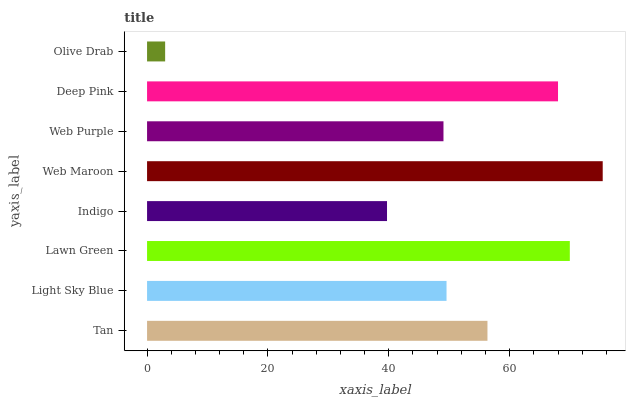Is Olive Drab the minimum?
Answer yes or no. Yes. Is Web Maroon the maximum?
Answer yes or no. Yes. Is Light Sky Blue the minimum?
Answer yes or no. No. Is Light Sky Blue the maximum?
Answer yes or no. No. Is Tan greater than Light Sky Blue?
Answer yes or no. Yes. Is Light Sky Blue less than Tan?
Answer yes or no. Yes. Is Light Sky Blue greater than Tan?
Answer yes or no. No. Is Tan less than Light Sky Blue?
Answer yes or no. No. Is Tan the high median?
Answer yes or no. Yes. Is Light Sky Blue the low median?
Answer yes or no. Yes. Is Olive Drab the high median?
Answer yes or no. No. Is Lawn Green the low median?
Answer yes or no. No. 